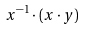<formula> <loc_0><loc_0><loc_500><loc_500>x ^ { - 1 } \cdot ( x \cdot y )</formula> 